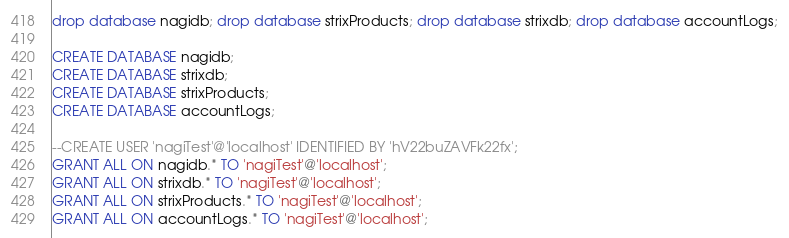<code> <loc_0><loc_0><loc_500><loc_500><_SQL_>drop database nagidb; drop database strixProducts; drop database strixdb; drop database accountLogs;

CREATE DATABASE nagidb;
CREATE DATABASE strixdb;
CREATE DATABASE strixProducts;
CREATE DATABASE accountLogs;

--CREATE USER 'nagiTest'@'localhost' IDENTIFIED BY 'hV22buZAVFk22fx';
GRANT ALL ON nagidb.* TO 'nagiTest'@'localhost';
GRANT ALL ON strixdb.* TO 'nagiTest'@'localhost';
GRANT ALL ON strixProducts.* TO 'nagiTest'@'localhost';
GRANT ALL ON accountLogs.* TO 'nagiTest'@'localhost';
</code> 